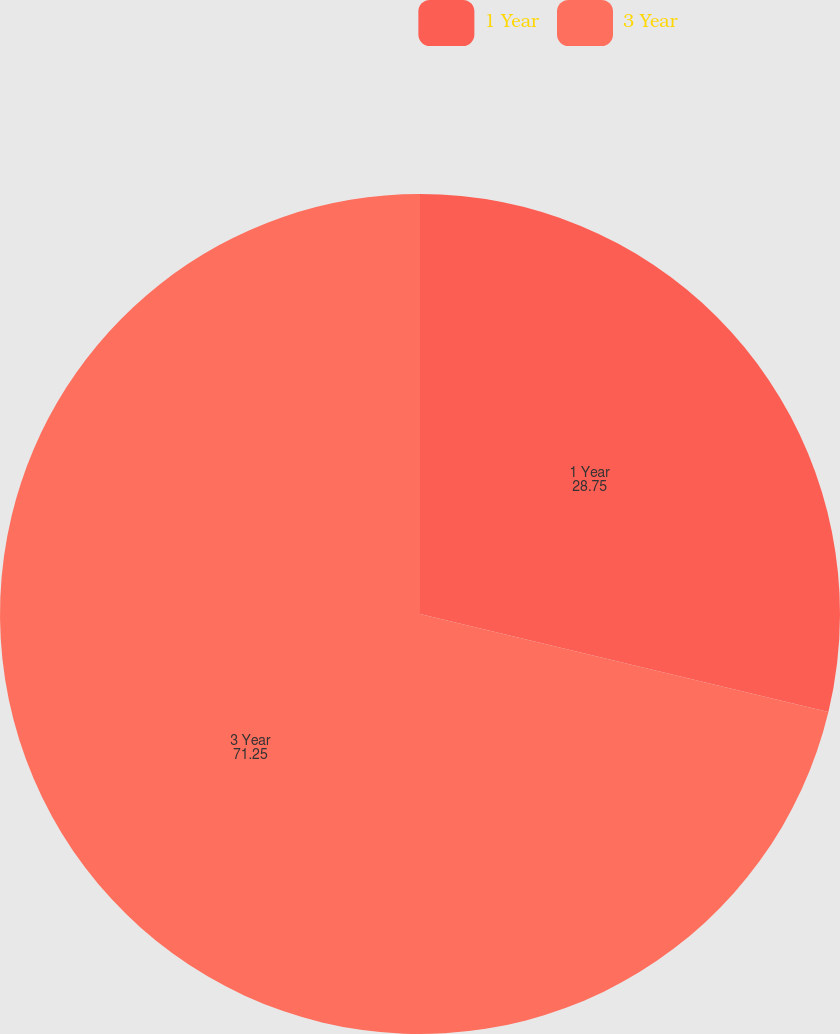Convert chart to OTSL. <chart><loc_0><loc_0><loc_500><loc_500><pie_chart><fcel>1 Year<fcel>3 Year<nl><fcel>28.75%<fcel>71.25%<nl></chart> 